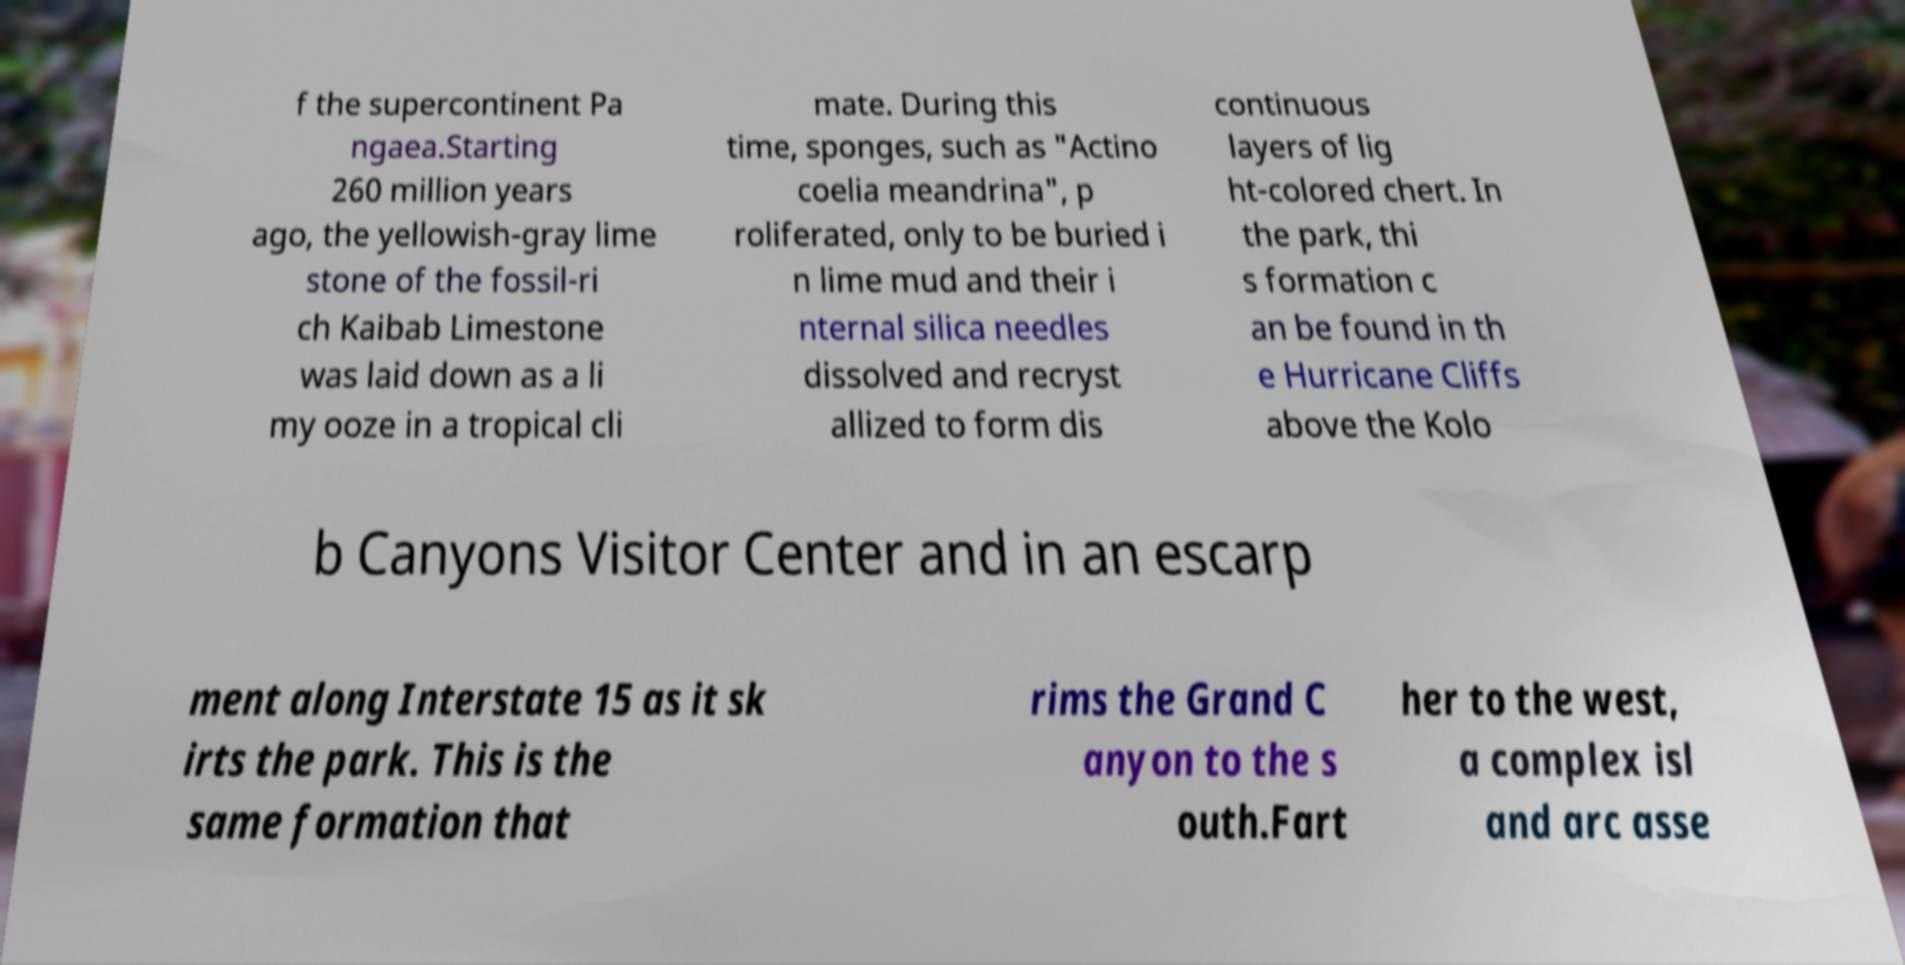I need the written content from this picture converted into text. Can you do that? f the supercontinent Pa ngaea.Starting 260 million years ago, the yellowish-gray lime stone of the fossil-ri ch Kaibab Limestone was laid down as a li my ooze in a tropical cli mate. During this time, sponges, such as "Actino coelia meandrina", p roliferated, only to be buried i n lime mud and their i nternal silica needles dissolved and recryst allized to form dis continuous layers of lig ht-colored chert. In the park, thi s formation c an be found in th e Hurricane Cliffs above the Kolo b Canyons Visitor Center and in an escarp ment along Interstate 15 as it sk irts the park. This is the same formation that rims the Grand C anyon to the s outh.Fart her to the west, a complex isl and arc asse 